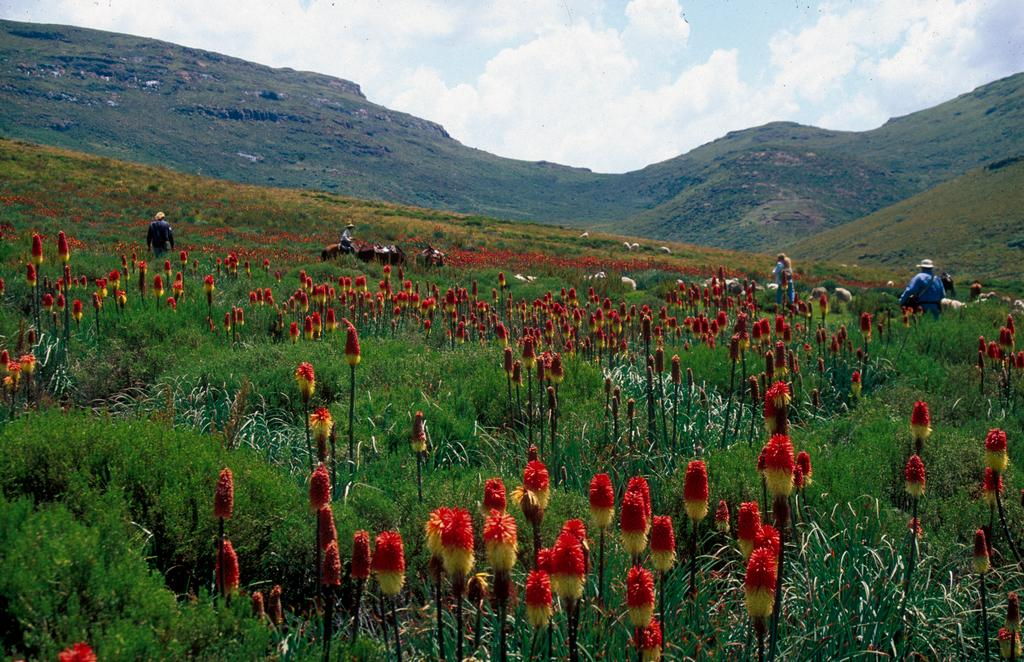What can be seen in the sky in the background of the image? There are clouds in the sky in the background of the image. What type of natural features are visible in the background of the image? There are hills in the background of the image. What other elements can be seen in the background of the image? There are people, plants, and animals in the background of the image. What type of attraction is present in the image, and how much does it cost to enter? There is no attraction present in the image, and therefore no cost to enter. Can you see a flame in the image? There is no flame present in the image. 